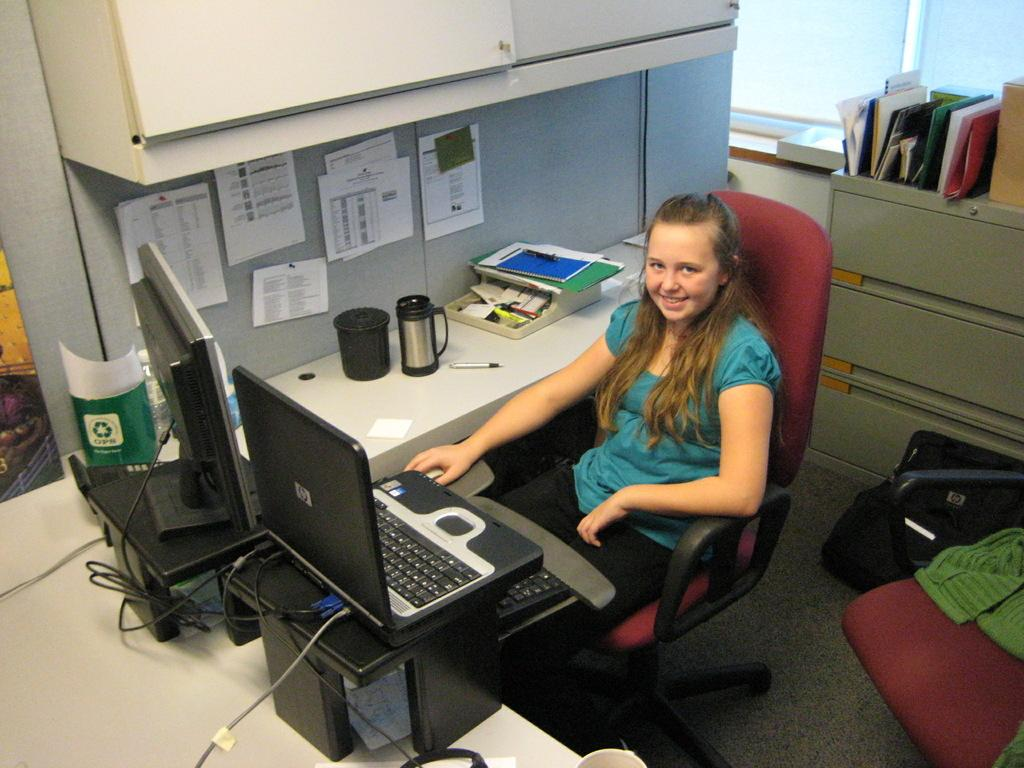What is the girl doing in the image? The girl is seated in the image. What is the girl sitting on? The girl is seated on a chair. What electronic devices are visible in the image? There is a laptop and a computer in the image. What items can be seen on the table in the image? There is a box and books on the table in the image. What is the girl holding in the image? The girl has a backpack in the image. What type of treatment is the girl receiving in the image? There is no indication in the image that the girl is receiving any treatment. How many times does the girl fold the chair in the image? The girl is not folding the chair in the image; she is seated on it. 